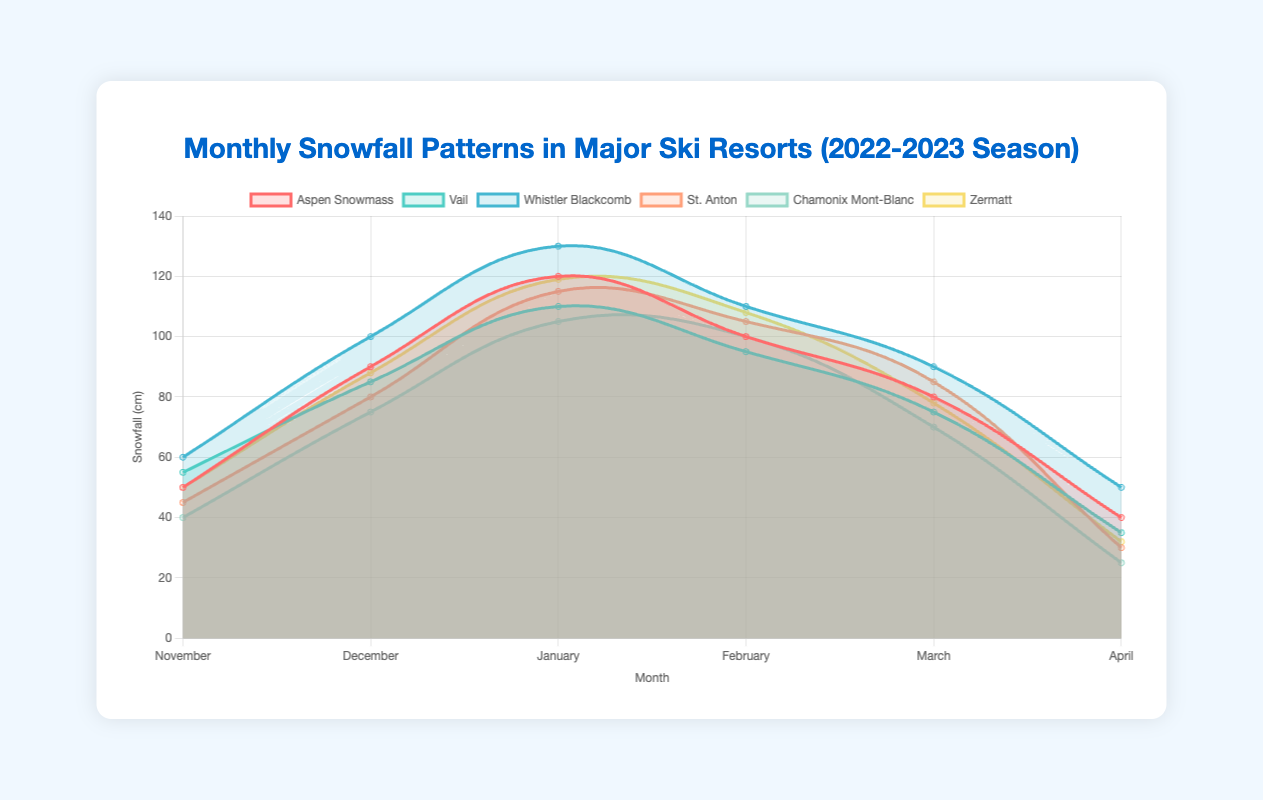How much more snowfall did Whistler Blackcomb receive in February compared to Chamonix Mont-Blanc? Whistler Blackcomb received 110 cm of snow in February, while Chamonix Mont-Blanc received 100 cm. The difference is 110 - 100.
Answer: 10 cm Which resort had the highest snowfall in January? By looking at the January data for each resort: Aspen Snowmass (120 cm), Vail (110 cm), Whistler Blackcomb (130 cm), St. Anton (115 cm), Chamonix Mont-Blanc (105 cm), and Zermatt (119 cm). Whistler Blackcomb had the highest snowfall at 130 cm.
Answer: Whistler Blackcomb Which month had the lowest snowfall for Vail? Vail's snowfall by month is: November (55 cm), December (85 cm), January (110 cm), February (95 cm), March (75 cm), and April (35 cm). The lowest snowfall was in April at 35 cm.
Answer: April How does the total snowfall for February across all resorts compare to the total for March? Summing the February snowfall: Aspen Snowmass (100 cm), Vail (95 cm), Whistler Blackcomb (110 cm), St. Anton (105 cm), Chamonix Mont-Blanc (100 cm), and Zermatt (108 cm) gives 618 cm. Summing March data: Aspen Snowmass (80 cm), Vail (75 cm), Whistler Blackcomb (90 cm), St. Anton (85 cm), Chamonix Mont-Blanc (70 cm), and Zermatt (78 cm) gives 478 cm. February's total is 618 cm which is greater than March's total of 478 cm by 140 cm.
Answer: 140 cm more in February In which month does Zermatt’s snowfall drop below 50 cm and stay there? Looking at Zermatt's monthly snowfall: November (50 cm), December (88 cm), January (119 cm), February (108 cm), March (78 cm), April (32 cm). From April onwards, it drops below 50 cm and stays there.
Answer: April Which resort had the most consistent snowfall from November to April? Examining the variations in snowfall across months: Aspen Snowmass (50, 90, 120, 100, 80, 40), Vail (55, 85, 110, 95, 75, 35), Whistler Blackcomb (60, 100, 130, 110, 90, 50), St. Anton (45, 80, 115, 105, 85, 30), Chamonix Mont-Blanc (40, 75, 105, 100, 70, 25), Zermatt (50, 88, 119, 108, 78, 32). Zermatt has the most consistency with less steep changes and a smoother drop.
Answer: Zermatt What is the average snowfall in December across all resorts? Summing December snowfall: Aspen Snowmass (90 cm), Vail (85 cm), Whistler Blackcomb (100 cm), St. Anton (80 cm), Chamonix Mont-Blanc (75 cm), and Zermatt (88 cm). Total is 518 cm. Average = 518 / 6 = 86.3 cm.
Answer: 86.3 cm 